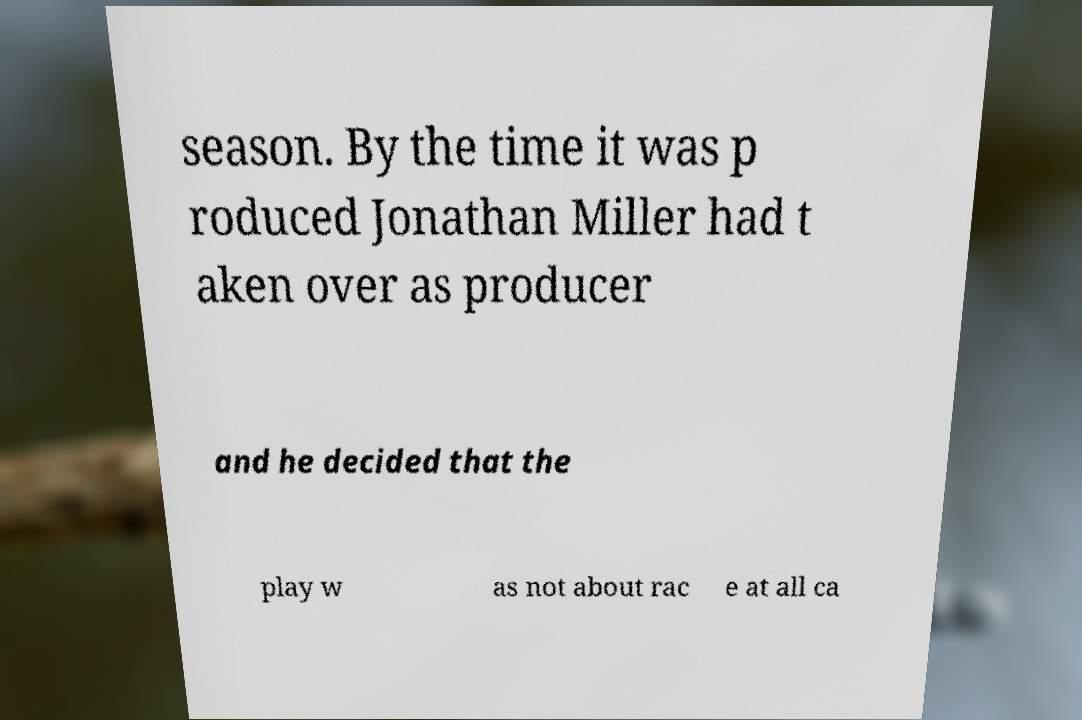Can you accurately transcribe the text from the provided image for me? season. By the time it was p roduced Jonathan Miller had t aken over as producer and he decided that the play w as not about rac e at all ca 